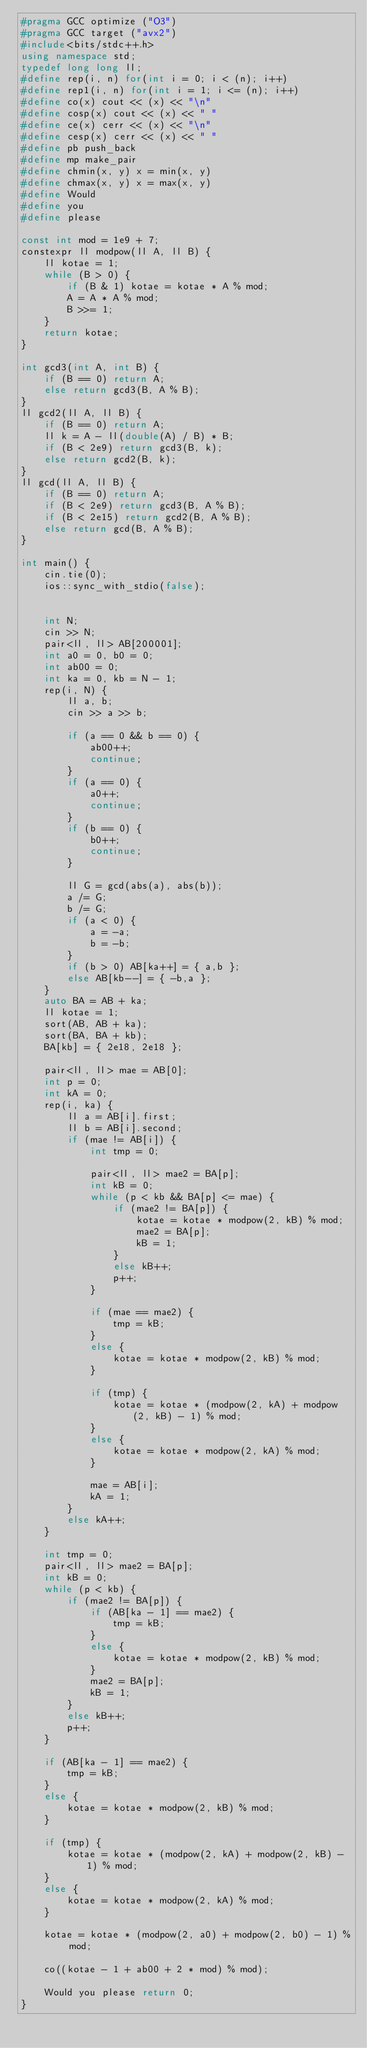<code> <loc_0><loc_0><loc_500><loc_500><_C++_>#pragma GCC optimize ("O3")
#pragma GCC target ("avx2")
#include<bits/stdc++.h>
using namespace std;
typedef long long ll;
#define rep(i, n) for(int i = 0; i < (n); i++)
#define rep1(i, n) for(int i = 1; i <= (n); i++)
#define co(x) cout << (x) << "\n"
#define cosp(x) cout << (x) << " "
#define ce(x) cerr << (x) << "\n"
#define cesp(x) cerr << (x) << " "
#define pb push_back
#define mp make_pair
#define chmin(x, y) x = min(x, y)
#define chmax(x, y) x = max(x, y)
#define Would
#define you
#define please

const int mod = 1e9 + 7;
constexpr ll modpow(ll A, ll B) {
	ll kotae = 1;
	while (B > 0) {
		if (B & 1) kotae = kotae * A % mod;
		A = A * A % mod;
		B >>= 1;
	}
	return kotae;
}

int gcd3(int A, int B) {
	if (B == 0) return A;
	else return gcd3(B, A % B);
}
ll gcd2(ll A, ll B) {
	if (B == 0) return A;
	ll k = A - ll(double(A) / B) * B;
	if (B < 2e9) return gcd3(B, k);
	else return gcd2(B, k);
}
ll gcd(ll A, ll B) {
	if (B == 0) return A;
	if (B < 2e9) return gcd3(B, A % B);
	if (B < 2e15) return gcd2(B, A % B);
	else return gcd(B, A % B);
}

int main() {
	cin.tie(0);
	ios::sync_with_stdio(false);


	int N;
	cin >> N;
	pair<ll, ll> AB[200001];
	int a0 = 0, b0 = 0;
	int ab00 = 0;
	int ka = 0, kb = N - 1;
	rep(i, N) {
		ll a, b;
		cin >> a >> b;

		if (a == 0 && b == 0) {
			ab00++;
			continue;
		}
		if (a == 0) {
			a0++;
			continue;
		}
		if (b == 0) {
			b0++;
			continue;
		}

		ll G = gcd(abs(a), abs(b));
		a /= G;
		b /= G;
		if (a < 0) {
			a = -a;
			b = -b;
		}
		if (b > 0) AB[ka++] = { a,b };
		else AB[kb--] = { -b,a };
	}
	auto BA = AB + ka;
	ll kotae = 1;
	sort(AB, AB + ka);
	sort(BA, BA + kb);
	BA[kb] = { 2e18, 2e18 };

	pair<ll, ll> mae = AB[0];
	int p = 0;
	int kA = 0;
	rep(i, ka) {
		ll a = AB[i].first;
		ll b = AB[i].second;
		if (mae != AB[i]) {
			int tmp = 0;

			pair<ll, ll> mae2 = BA[p];
			int kB = 0;
			while (p < kb && BA[p] <= mae) {
				if (mae2 != BA[p]) {
					kotae = kotae * modpow(2, kB) % mod;
					mae2 = BA[p];
					kB = 1;
				}
				else kB++;
				p++;
			}

			if (mae == mae2) {
				tmp = kB;
			}
			else {
				kotae = kotae * modpow(2, kB) % mod;
			}

			if (tmp) {
				kotae = kotae * (modpow(2, kA) + modpow(2, kB) - 1) % mod;
			}
			else {
				kotae = kotae * modpow(2, kA) % mod;
			}

			mae = AB[i];
			kA = 1;
		}
		else kA++;
	}

	int tmp = 0;
	pair<ll, ll> mae2 = BA[p];
	int kB = 0;
	while (p < kb) {
		if (mae2 != BA[p]) {
			if (AB[ka - 1] == mae2) {
				tmp = kB;
			}
			else {
				kotae = kotae * modpow(2, kB) % mod;
			}
			mae2 = BA[p];
			kB = 1;
		}
		else kB++;
		p++;
	}

	if (AB[ka - 1] == mae2) {
		tmp = kB;
	}
	else {
		kotae = kotae * modpow(2, kB) % mod;
	}

	if (tmp) {
		kotae = kotae * (modpow(2, kA) + modpow(2, kB) - 1) % mod;
	}
	else {
		kotae = kotae * modpow(2, kA) % mod;
	}

	kotae = kotae * (modpow(2, a0) + modpow(2, b0) - 1) % mod;

	co((kotae - 1 + ab00 + 2 * mod) % mod);

	Would you please return 0;
}</code> 